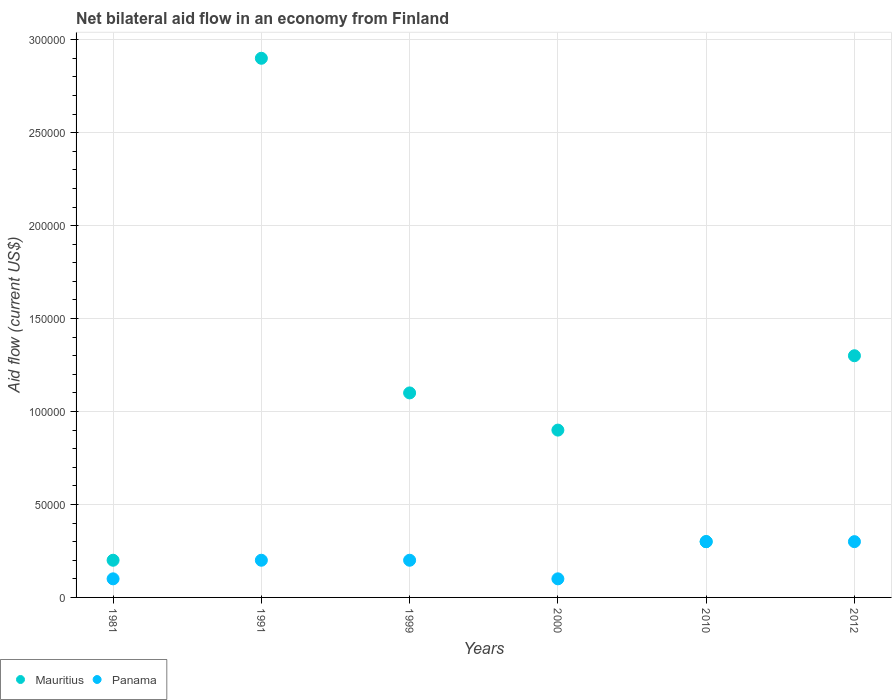Across all years, what is the maximum net bilateral aid flow in Mauritius?
Keep it short and to the point. 2.90e+05. Across all years, what is the minimum net bilateral aid flow in Panama?
Provide a succinct answer. 10000. In which year was the net bilateral aid flow in Mauritius maximum?
Your answer should be very brief. 1991. In which year was the net bilateral aid flow in Panama minimum?
Make the answer very short. 1981. What is the total net bilateral aid flow in Mauritius in the graph?
Make the answer very short. 6.70e+05. What is the difference between the net bilateral aid flow in Mauritius in 1981 and that in 2000?
Keep it short and to the point. -7.00e+04. What is the difference between the net bilateral aid flow in Mauritius in 1999 and the net bilateral aid flow in Panama in 2010?
Offer a very short reply. 8.00e+04. What is the average net bilateral aid flow in Panama per year?
Provide a short and direct response. 2.00e+04. In how many years, is the net bilateral aid flow in Panama greater than 60000 US$?
Your answer should be very brief. 0. What is the ratio of the net bilateral aid flow in Mauritius in 1999 to that in 2000?
Offer a very short reply. 1.22. Is the net bilateral aid flow in Mauritius in 1991 less than that in 1999?
Provide a succinct answer. No. Is the difference between the net bilateral aid flow in Mauritius in 1991 and 2010 greater than the difference between the net bilateral aid flow in Panama in 1991 and 2010?
Your response must be concise. Yes. What is the difference between the highest and the lowest net bilateral aid flow in Mauritius?
Provide a succinct answer. 2.70e+05. Is the sum of the net bilateral aid flow in Panama in 1981 and 1991 greater than the maximum net bilateral aid flow in Mauritius across all years?
Make the answer very short. No. Is the net bilateral aid flow in Mauritius strictly less than the net bilateral aid flow in Panama over the years?
Provide a short and direct response. No. Are the values on the major ticks of Y-axis written in scientific E-notation?
Give a very brief answer. No. Does the graph contain any zero values?
Give a very brief answer. No. Does the graph contain grids?
Your response must be concise. Yes. How many legend labels are there?
Provide a succinct answer. 2. What is the title of the graph?
Ensure brevity in your answer.  Net bilateral aid flow in an economy from Finland. Does "Mozambique" appear as one of the legend labels in the graph?
Provide a succinct answer. No. What is the label or title of the Y-axis?
Your answer should be very brief. Aid flow (current US$). What is the Aid flow (current US$) in Mauritius in 1981?
Provide a succinct answer. 2.00e+04. What is the Aid flow (current US$) in Mauritius in 1999?
Ensure brevity in your answer.  1.10e+05. What is the Aid flow (current US$) in Mauritius in 2010?
Your response must be concise. 3.00e+04. What is the Aid flow (current US$) in Panama in 2010?
Offer a very short reply. 3.00e+04. Across all years, what is the minimum Aid flow (current US$) in Mauritius?
Your answer should be very brief. 2.00e+04. Across all years, what is the minimum Aid flow (current US$) in Panama?
Provide a succinct answer. 10000. What is the total Aid flow (current US$) in Mauritius in the graph?
Offer a very short reply. 6.70e+05. What is the total Aid flow (current US$) of Panama in the graph?
Provide a succinct answer. 1.20e+05. What is the difference between the Aid flow (current US$) in Mauritius in 1981 and that in 1991?
Your response must be concise. -2.70e+05. What is the difference between the Aid flow (current US$) in Mauritius in 1981 and that in 2000?
Your response must be concise. -7.00e+04. What is the difference between the Aid flow (current US$) in Mauritius in 1981 and that in 2012?
Provide a short and direct response. -1.10e+05. What is the difference between the Aid flow (current US$) in Mauritius in 1991 and that in 1999?
Make the answer very short. 1.80e+05. What is the difference between the Aid flow (current US$) in Panama in 1991 and that in 2000?
Your response must be concise. 10000. What is the difference between the Aid flow (current US$) in Panama in 1991 and that in 2012?
Offer a terse response. -10000. What is the difference between the Aid flow (current US$) of Mauritius in 1999 and that in 2000?
Offer a terse response. 2.00e+04. What is the difference between the Aid flow (current US$) of Mauritius in 1999 and that in 2010?
Make the answer very short. 8.00e+04. What is the difference between the Aid flow (current US$) of Panama in 1999 and that in 2010?
Give a very brief answer. -10000. What is the difference between the Aid flow (current US$) in Mauritius in 2010 and that in 2012?
Offer a terse response. -1.00e+05. What is the difference between the Aid flow (current US$) in Panama in 2010 and that in 2012?
Make the answer very short. 0. What is the difference between the Aid flow (current US$) in Mauritius in 1981 and the Aid flow (current US$) in Panama in 1999?
Keep it short and to the point. 0. What is the difference between the Aid flow (current US$) in Mauritius in 1981 and the Aid flow (current US$) in Panama in 2010?
Provide a succinct answer. -10000. What is the difference between the Aid flow (current US$) of Mauritius in 1991 and the Aid flow (current US$) of Panama in 1999?
Offer a very short reply. 2.70e+05. What is the difference between the Aid flow (current US$) of Mauritius in 1991 and the Aid flow (current US$) of Panama in 2000?
Keep it short and to the point. 2.80e+05. What is the difference between the Aid flow (current US$) of Mauritius in 1991 and the Aid flow (current US$) of Panama in 2010?
Your answer should be very brief. 2.60e+05. What is the difference between the Aid flow (current US$) of Mauritius in 1991 and the Aid flow (current US$) of Panama in 2012?
Ensure brevity in your answer.  2.60e+05. What is the difference between the Aid flow (current US$) of Mauritius in 1999 and the Aid flow (current US$) of Panama in 2010?
Your response must be concise. 8.00e+04. What is the difference between the Aid flow (current US$) in Mauritius in 1999 and the Aid flow (current US$) in Panama in 2012?
Give a very brief answer. 8.00e+04. What is the difference between the Aid flow (current US$) in Mauritius in 2000 and the Aid flow (current US$) in Panama in 2010?
Your response must be concise. 6.00e+04. What is the difference between the Aid flow (current US$) in Mauritius in 2000 and the Aid flow (current US$) in Panama in 2012?
Provide a succinct answer. 6.00e+04. What is the difference between the Aid flow (current US$) of Mauritius in 2010 and the Aid flow (current US$) of Panama in 2012?
Give a very brief answer. 0. What is the average Aid flow (current US$) of Mauritius per year?
Offer a terse response. 1.12e+05. What is the average Aid flow (current US$) in Panama per year?
Your answer should be very brief. 2.00e+04. In the year 2000, what is the difference between the Aid flow (current US$) in Mauritius and Aid flow (current US$) in Panama?
Your answer should be very brief. 8.00e+04. What is the ratio of the Aid flow (current US$) in Mauritius in 1981 to that in 1991?
Offer a very short reply. 0.07. What is the ratio of the Aid flow (current US$) of Panama in 1981 to that in 1991?
Make the answer very short. 0.5. What is the ratio of the Aid flow (current US$) of Mauritius in 1981 to that in 1999?
Provide a succinct answer. 0.18. What is the ratio of the Aid flow (current US$) in Panama in 1981 to that in 1999?
Offer a very short reply. 0.5. What is the ratio of the Aid flow (current US$) of Mauritius in 1981 to that in 2000?
Provide a short and direct response. 0.22. What is the ratio of the Aid flow (current US$) of Panama in 1981 to that in 2010?
Provide a succinct answer. 0.33. What is the ratio of the Aid flow (current US$) of Mauritius in 1981 to that in 2012?
Offer a very short reply. 0.15. What is the ratio of the Aid flow (current US$) of Mauritius in 1991 to that in 1999?
Your answer should be compact. 2.64. What is the ratio of the Aid flow (current US$) in Mauritius in 1991 to that in 2000?
Your answer should be very brief. 3.22. What is the ratio of the Aid flow (current US$) in Mauritius in 1991 to that in 2010?
Ensure brevity in your answer.  9.67. What is the ratio of the Aid flow (current US$) in Panama in 1991 to that in 2010?
Give a very brief answer. 0.67. What is the ratio of the Aid flow (current US$) in Mauritius in 1991 to that in 2012?
Make the answer very short. 2.23. What is the ratio of the Aid flow (current US$) of Panama in 1991 to that in 2012?
Ensure brevity in your answer.  0.67. What is the ratio of the Aid flow (current US$) in Mauritius in 1999 to that in 2000?
Provide a succinct answer. 1.22. What is the ratio of the Aid flow (current US$) in Mauritius in 1999 to that in 2010?
Keep it short and to the point. 3.67. What is the ratio of the Aid flow (current US$) in Mauritius in 1999 to that in 2012?
Provide a short and direct response. 0.85. What is the ratio of the Aid flow (current US$) of Panama in 1999 to that in 2012?
Offer a terse response. 0.67. What is the ratio of the Aid flow (current US$) of Mauritius in 2000 to that in 2012?
Provide a succinct answer. 0.69. What is the ratio of the Aid flow (current US$) of Panama in 2000 to that in 2012?
Offer a terse response. 0.33. What is the ratio of the Aid flow (current US$) of Mauritius in 2010 to that in 2012?
Offer a very short reply. 0.23. What is the difference between the highest and the second highest Aid flow (current US$) of Mauritius?
Your answer should be very brief. 1.60e+05. What is the difference between the highest and the lowest Aid flow (current US$) in Panama?
Your response must be concise. 2.00e+04. 